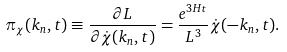Convert formula to latex. <formula><loc_0><loc_0><loc_500><loc_500>\pi _ { \chi } ( { k } _ { n } , t ) \equiv \frac { \partial L } { \partial { \dot { \chi } } ( { k } _ { n } , t ) } = \frac { e ^ { 3 H t } } { L ^ { 3 } } { \dot { \chi } } ( - { k } _ { n } , t ) .</formula> 